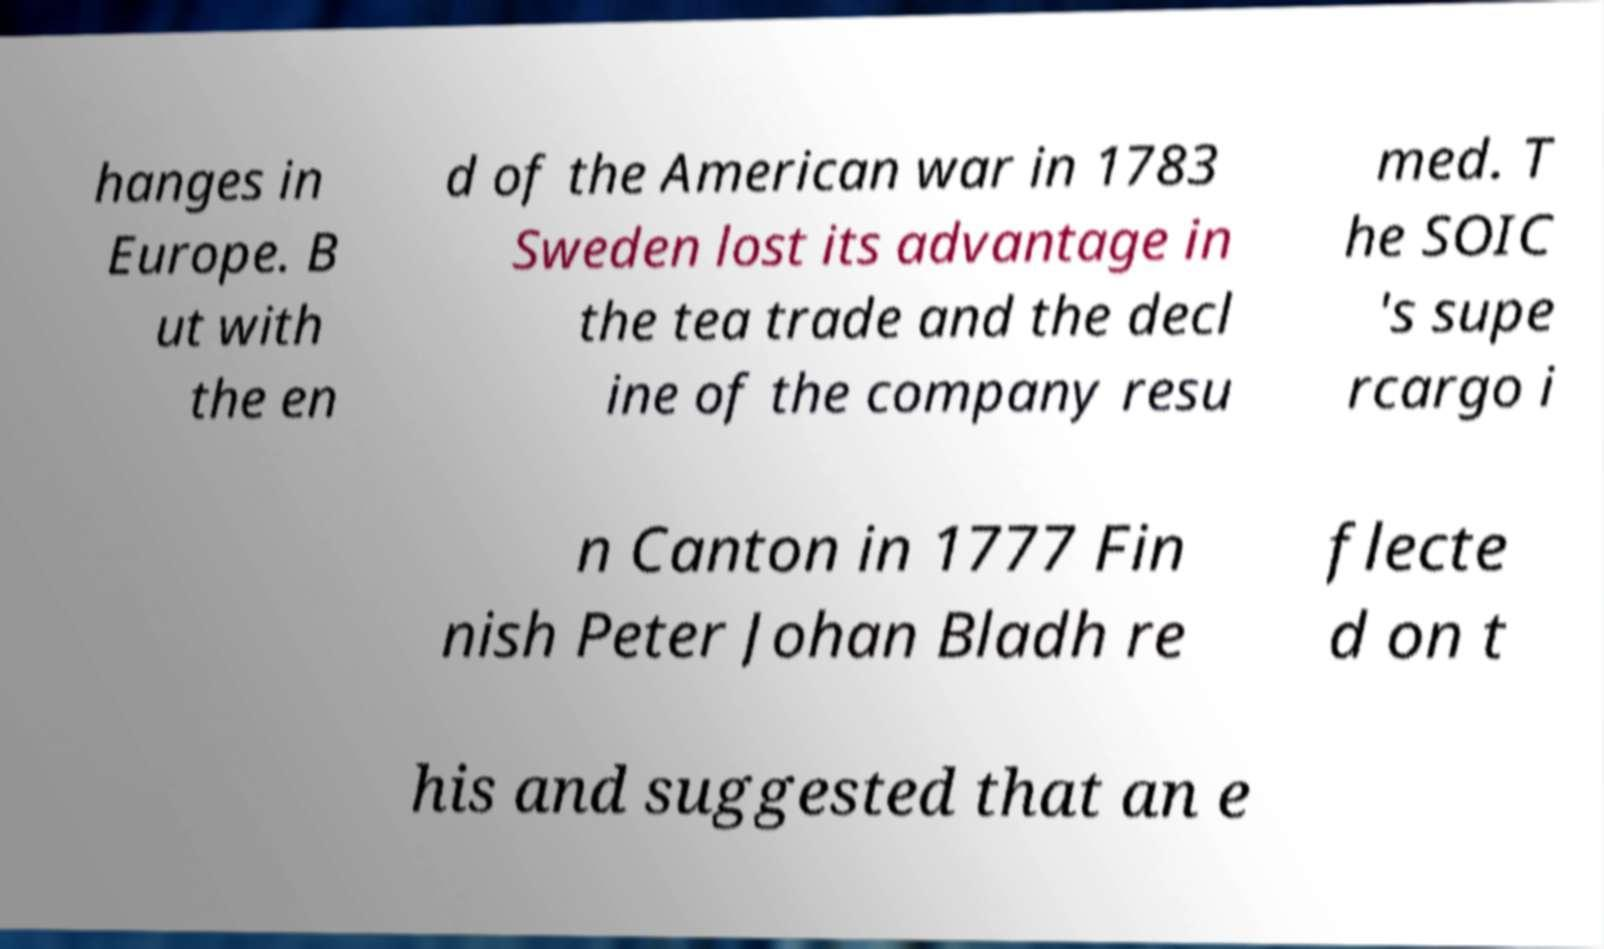Could you assist in decoding the text presented in this image and type it out clearly? hanges in Europe. B ut with the en d of the American war in 1783 Sweden lost its advantage in the tea trade and the decl ine of the company resu med. T he SOIC 's supe rcargo i n Canton in 1777 Fin nish Peter Johan Bladh re flecte d on t his and suggested that an e 